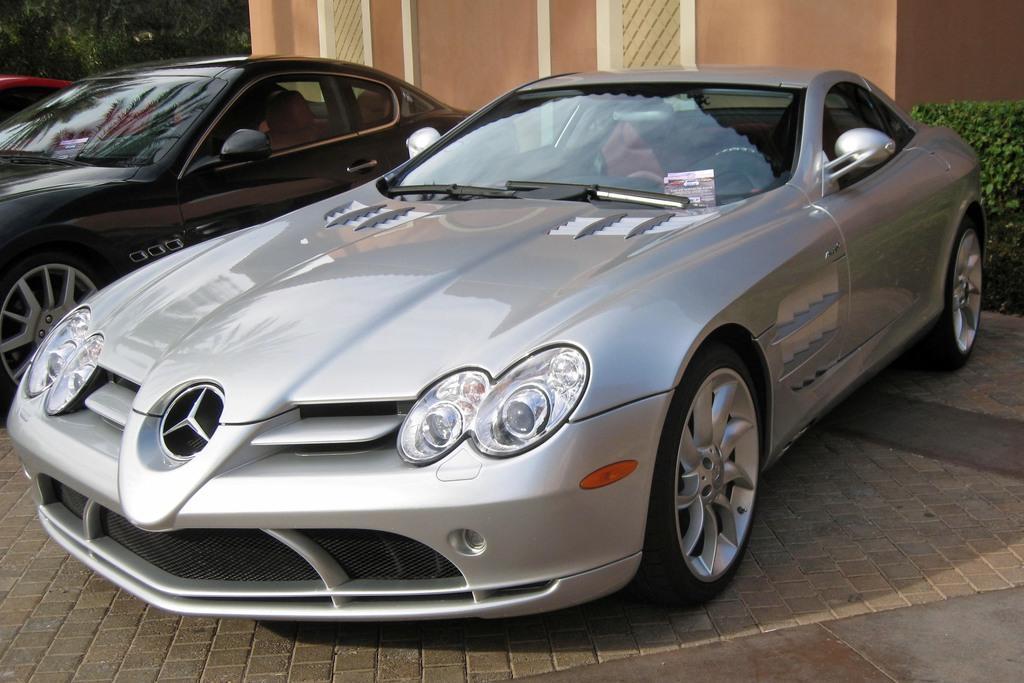How would you summarize this image in a sentence or two? In the foreground of the picture there are cars. On the right there is a plant. On the left there are trees. In the center of the background there is a building. 